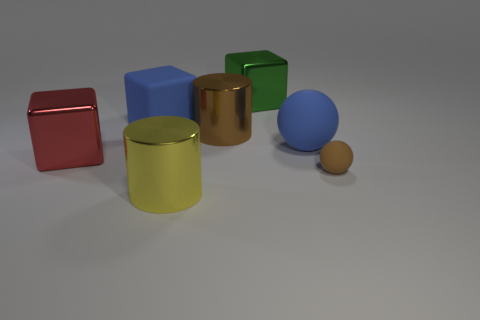Add 3 blue balls. How many objects exist? 10 Subtract all cubes. How many objects are left? 4 Subtract 0 gray spheres. How many objects are left? 7 Subtract all green cubes. Subtract all brown shiny objects. How many objects are left? 5 Add 6 big brown metallic cylinders. How many big brown metallic cylinders are left? 7 Add 1 matte cubes. How many matte cubes exist? 2 